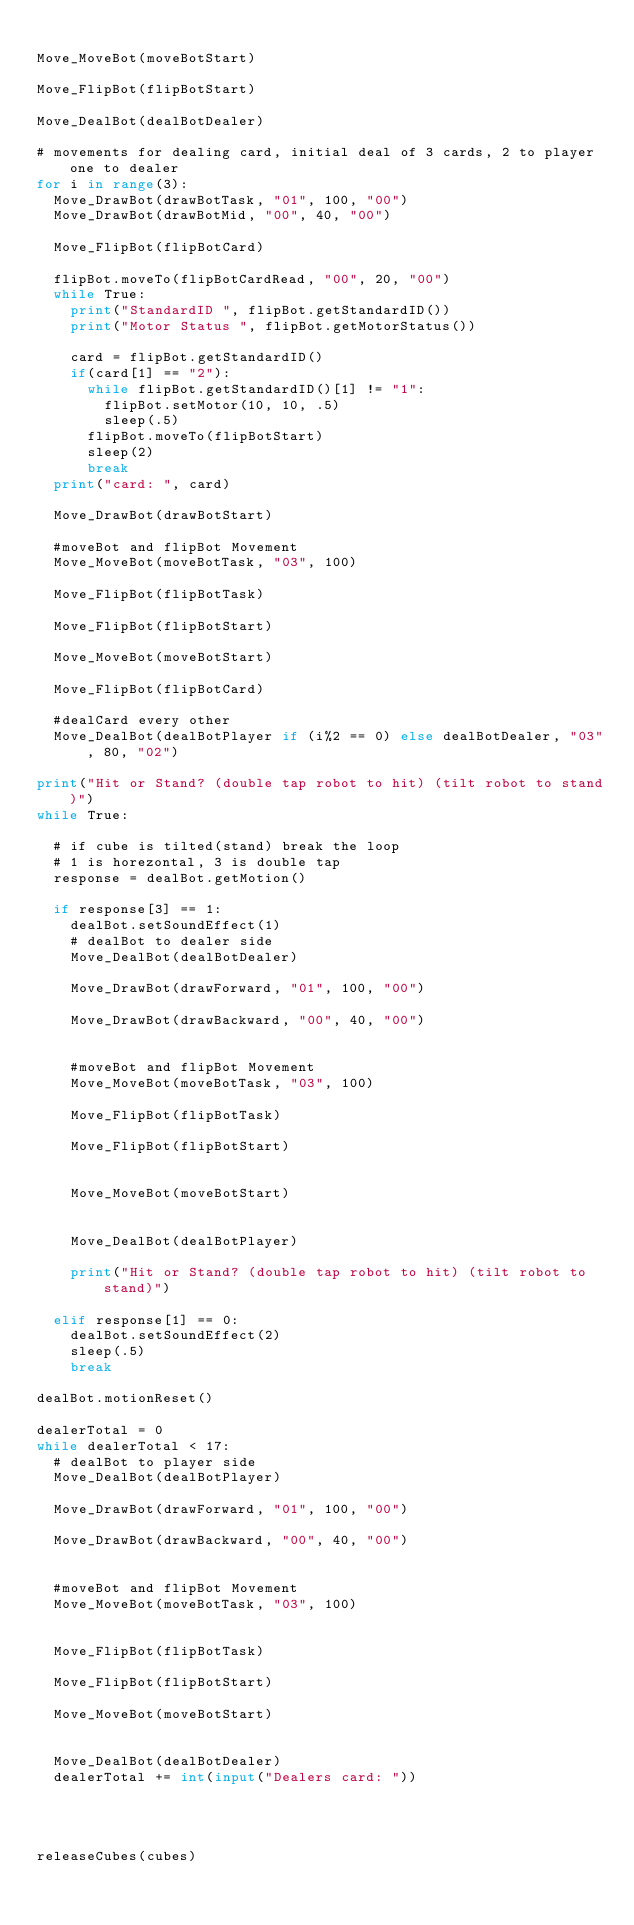Convert code to text. <code><loc_0><loc_0><loc_500><loc_500><_Python_>
Move_MoveBot(moveBotStart)

Move_FlipBot(flipBotStart)

Move_DealBot(dealBotDealer)

# movements for dealing card, initial deal of 3 cards, 2 to player one to dealer
for i in range(3):
	Move_DrawBot(drawBotTask, "01", 100, "00")
	Move_DrawBot(drawBotMid, "00", 40, "00")

	Move_FlipBot(flipBotCard)

	flipBot.moveTo(flipBotCardRead, "00", 20, "00")
	while True:
		print("StandardID ", flipBot.getStandardID())
		print("Motor Status ", flipBot.getMotorStatus())

		card = flipBot.getStandardID()
		if(card[1] == "2"):
			while flipBot.getStandardID()[1] != "1":
				flipBot.setMotor(10, 10, .5)
				sleep(.5)
			flipBot.moveTo(flipBotStart)
			sleep(2)
			break
	print("card: ", card)

	Move_DrawBot(drawBotStart)

	#moveBot and flipBot Movement
	Move_MoveBot(moveBotTask, "03", 100)

	Move_FlipBot(flipBotTask)

	Move_FlipBot(flipBotStart)

	Move_MoveBot(moveBotStart)

	Move_FlipBot(flipBotCard)

	#dealCard every other
	Move_DealBot(dealBotPlayer if (i%2 == 0) else dealBotDealer, "03", 80, "02")

print("Hit or Stand? (double tap robot to hit) (tilt robot to stand)")
while True:

	# if cube is tilted(stand) break the loop
	# 1 is horezontal, 3 is double tap
	response = dealBot.getMotion()

	if response[3] == 1:
		dealBot.setSoundEffect(1)
		# dealBot to dealer side
		Move_DealBot(dealBotDealer)

		Move_DrawBot(drawForward, "01", 100, "00")

		Move_DrawBot(drawBackward, "00", 40, "00")


		#moveBot and flipBot Movement
		Move_MoveBot(moveBotTask, "03", 100)

		Move_FlipBot(flipBotTask)

		Move_FlipBot(flipBotStart)


		Move_MoveBot(moveBotStart)


		Move_DealBot(dealBotPlayer)

		print("Hit or Stand? (double tap robot to hit) (tilt robot to stand)")

	elif response[1] == 0:
		dealBot.setSoundEffect(2)
		sleep(.5)
		break

dealBot.motionReset()

dealerTotal = 0
while dealerTotal < 17:
	# dealBot to player side
	Move_DealBot(dealBotPlayer)

	Move_DrawBot(drawForward, "01", 100, "00")

	Move_DrawBot(drawBackward, "00", 40, "00")


	#moveBot and flipBot Movement
	Move_MoveBot(moveBotTask, "03", 100)


	Move_FlipBot(flipBotTask)

	Move_FlipBot(flipBotStart)

	Move_MoveBot(moveBotStart)


	Move_DealBot(dealBotDealer)
	dealerTotal += int(input("Dealers card: "))




releaseCubes(cubes)</code> 